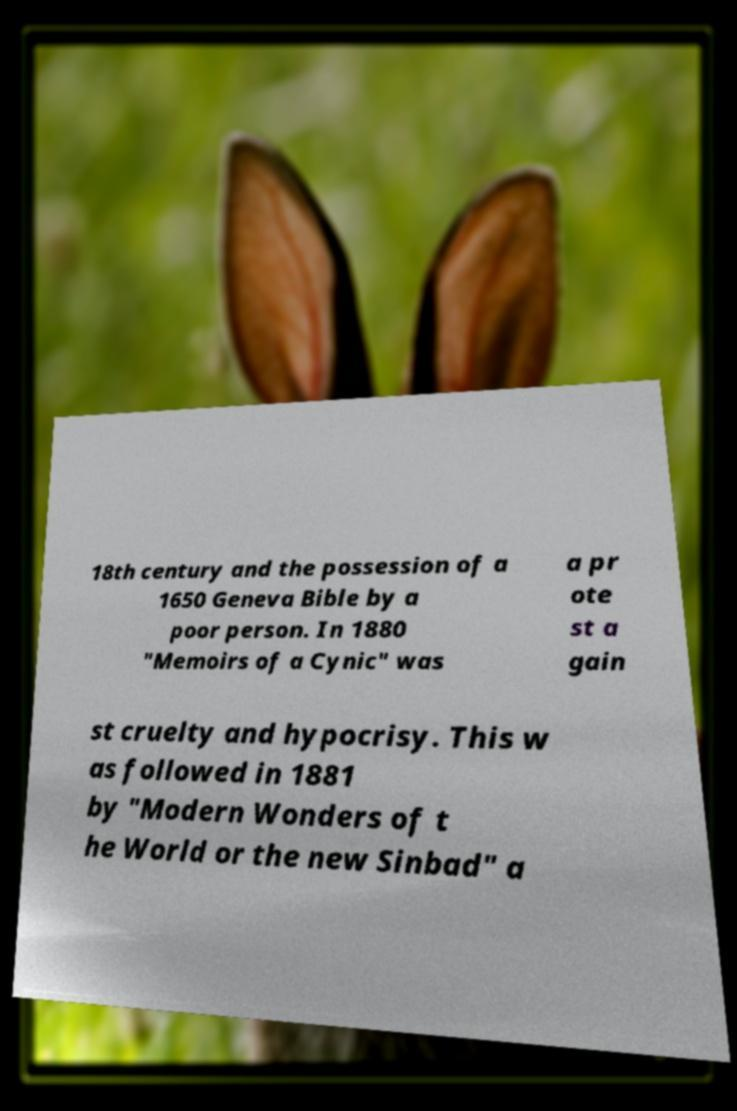Please identify and transcribe the text found in this image. 18th century and the possession of a 1650 Geneva Bible by a poor person. In 1880 "Memoirs of a Cynic" was a pr ote st a gain st cruelty and hypocrisy. This w as followed in 1881 by "Modern Wonders of t he World or the new Sinbad" a 